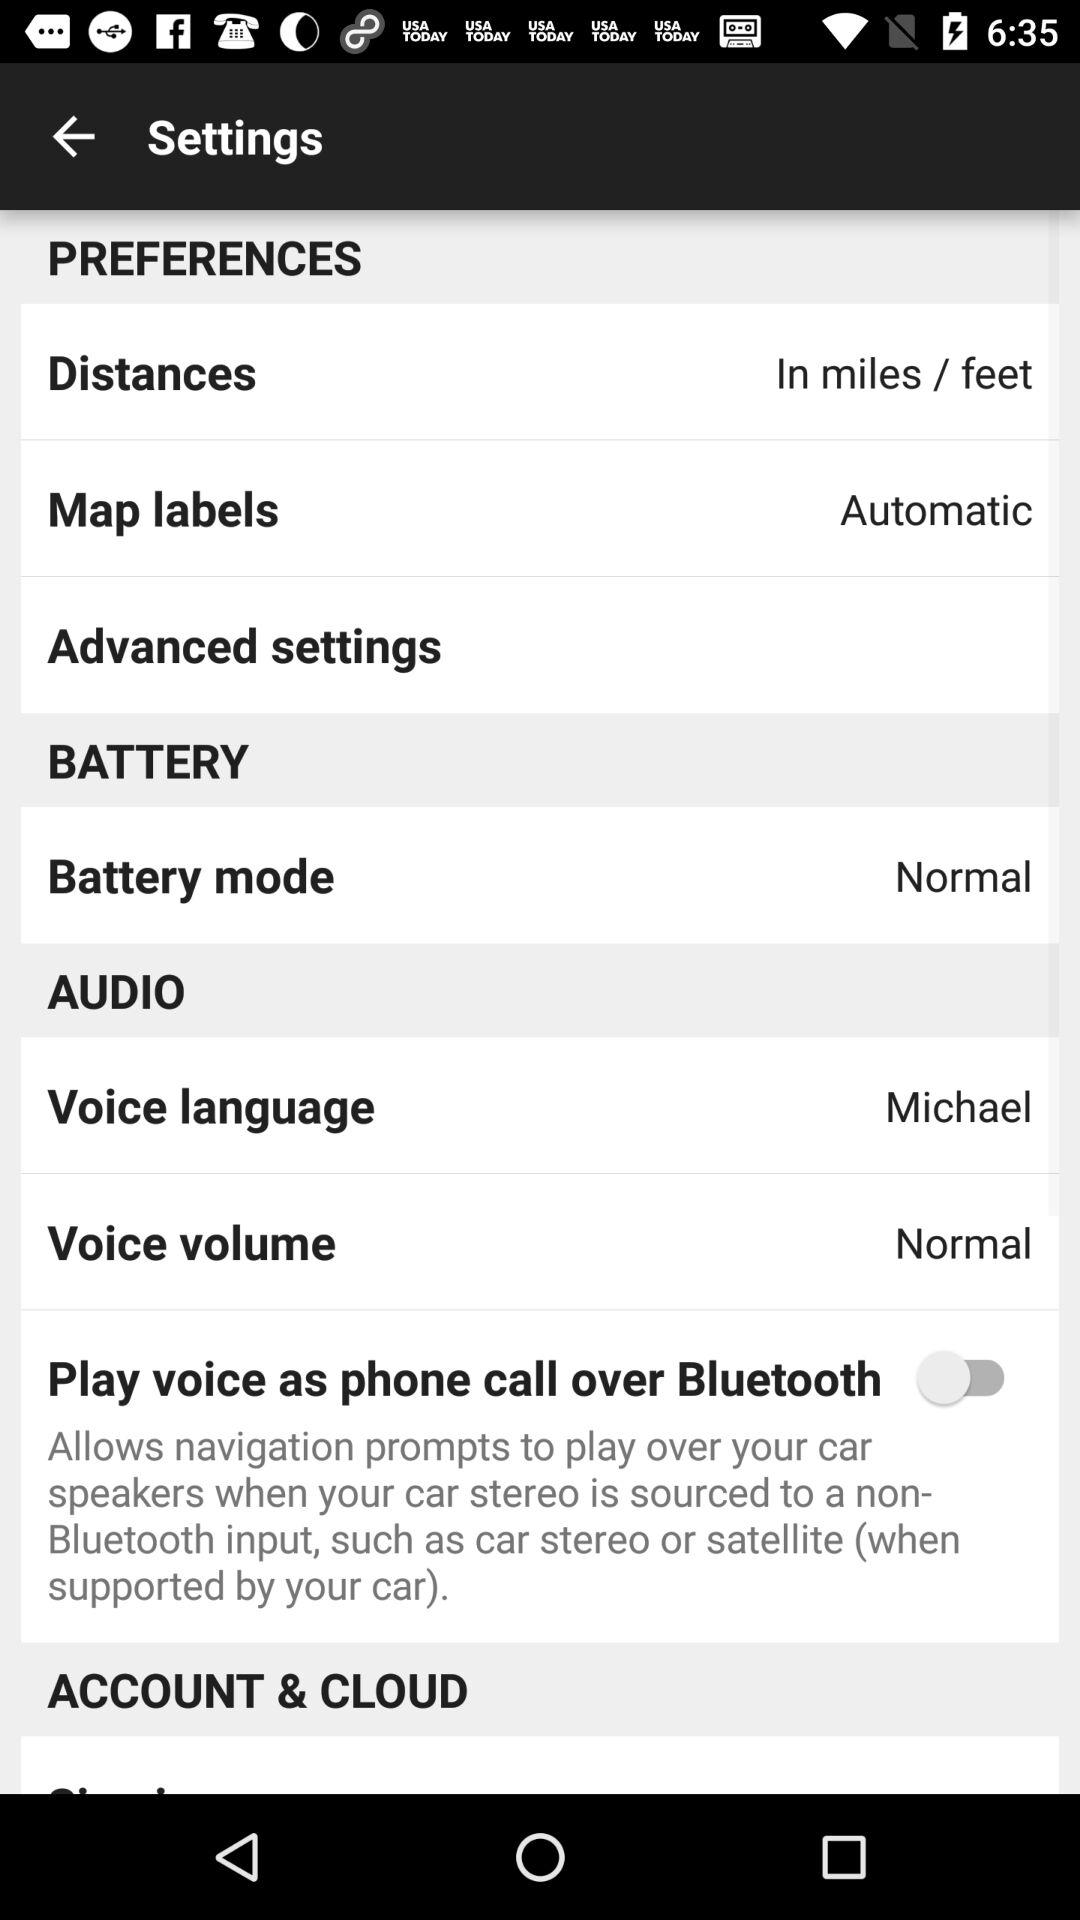What is the "Battery mode"?
Answer the question using a single word or phrase. It is normal. 